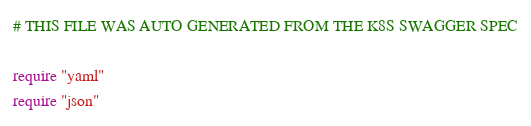Convert code to text. <code><loc_0><loc_0><loc_500><loc_500><_Crystal_># THIS FILE WAS AUTO GENERATED FROM THE K8S SWAGGER SPEC

require "yaml"
require "json"
</code> 